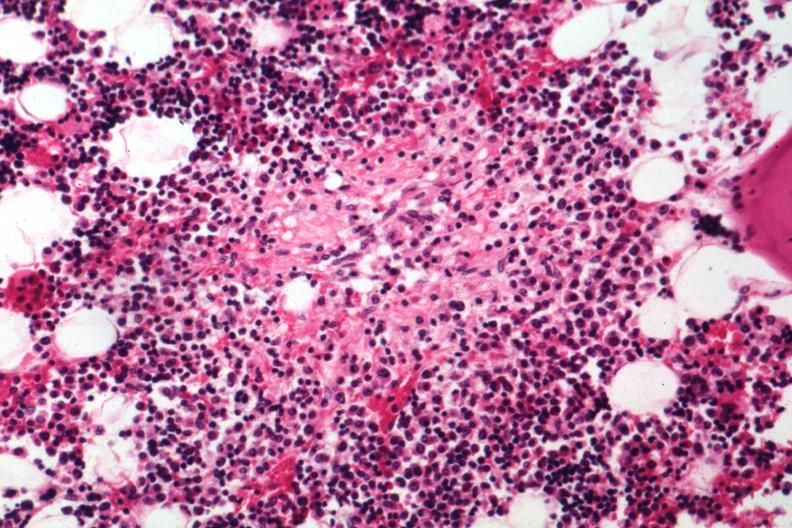s hand present?
Answer the question using a single word or phrase. No 